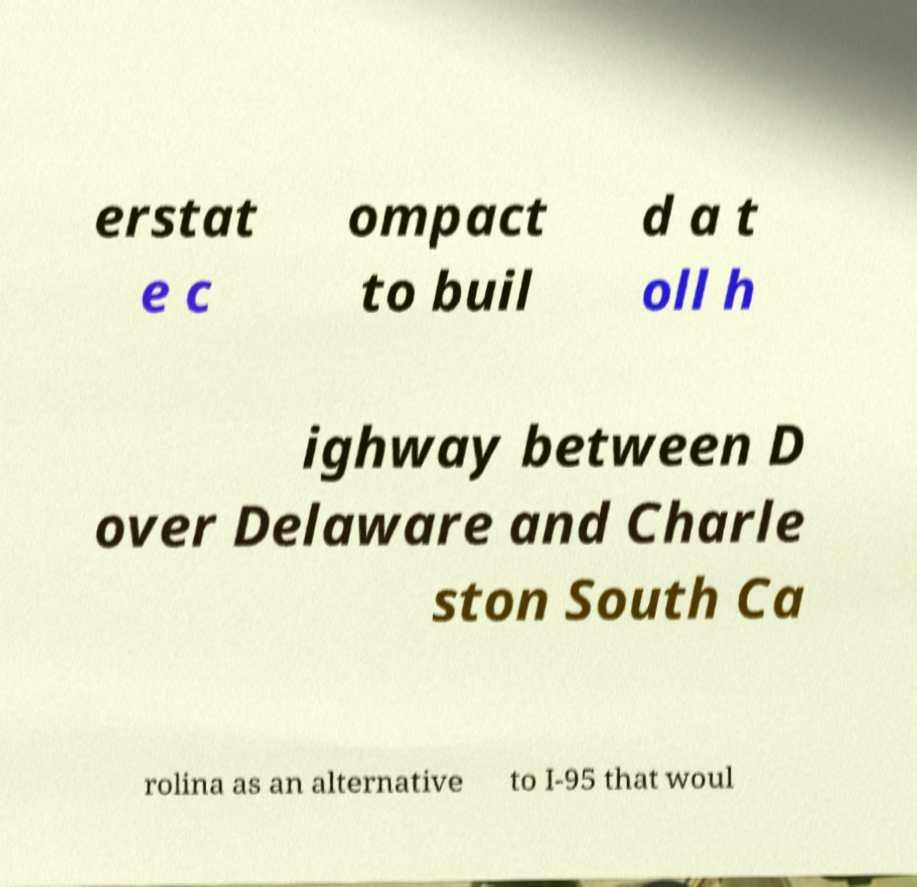Can you accurately transcribe the text from the provided image for me? erstat e c ompact to buil d a t oll h ighway between D over Delaware and Charle ston South Ca rolina as an alternative to I-95 that woul 